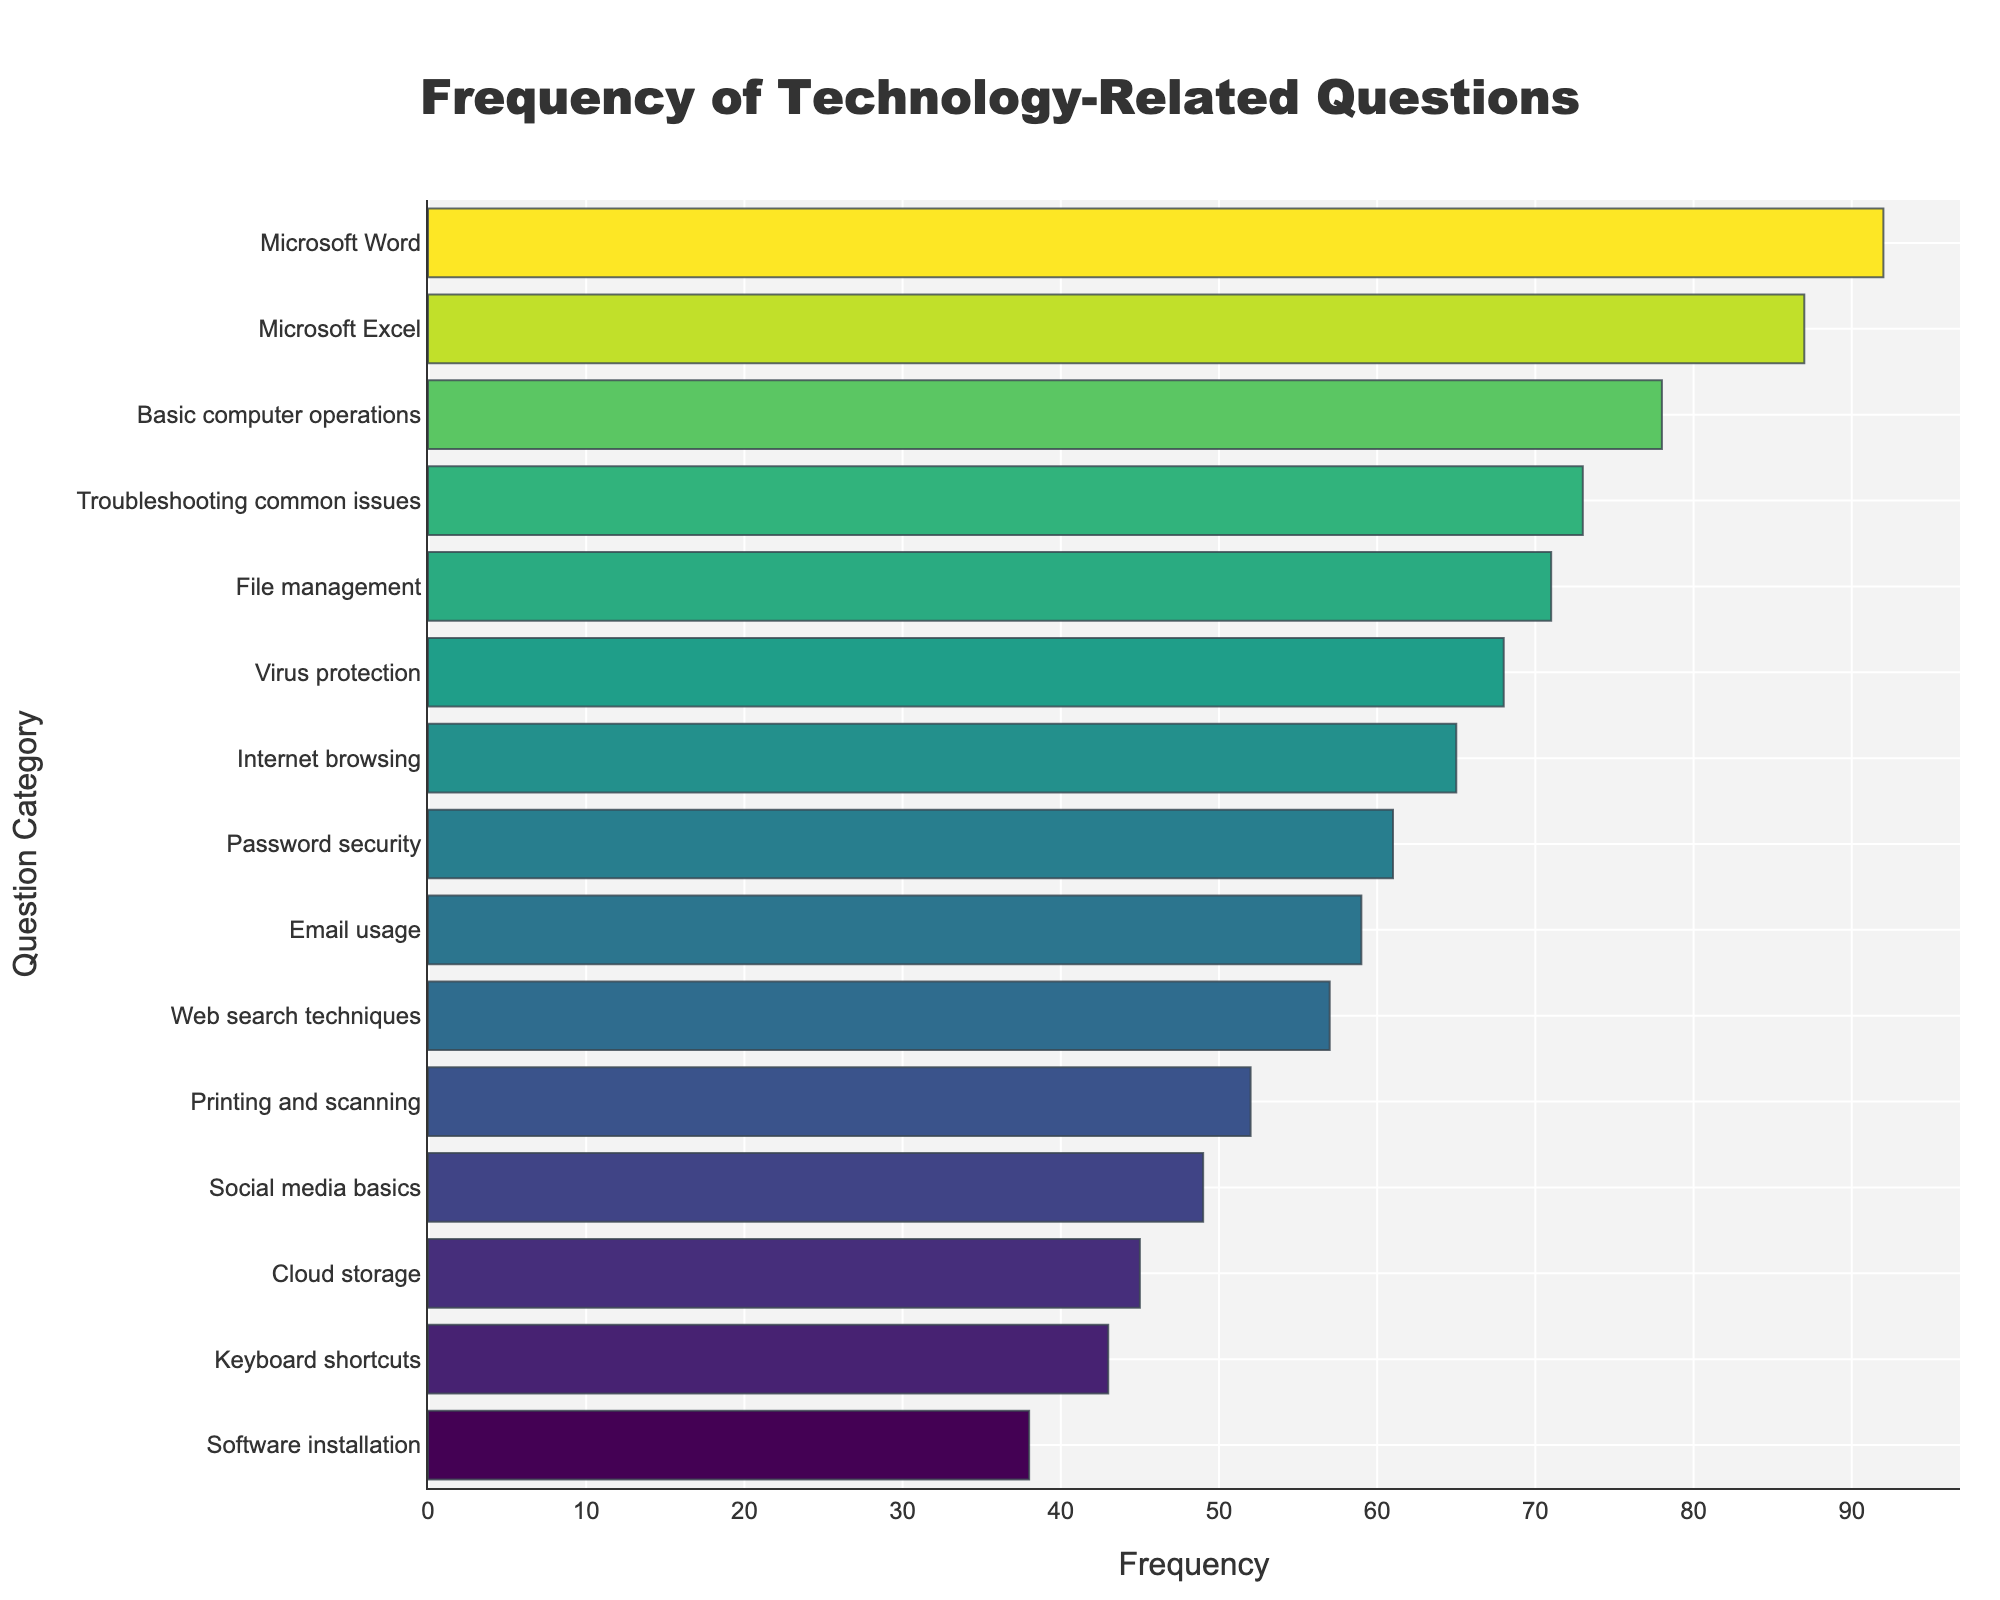What's the title of the figure? The title is usually displayed prominently at the top of the figure. Here, it reads 'Frequency of Technology-Related Questions'.
Answer: Frequency of Technology-Related Questions How many question categories are represented in the figure? To find this, count the number of distinct bars on the plot. Each bar represents a unique question category.
Answer: 15 Which question has the highest frequency? Look at the bar that extends the farthest to the right; this represents the highest frequency. 'Microsoft Word' appears to have the longest bar.
Answer: Microsoft Word What's the frequency of "Software installation" questions? Locate the bar corresponding to 'Software installation' and look at its length or corresponding value on the x-axis. The frequency is visible next to this bar.
Answer: 38 How does the frequency of 'Password security' compare to 'Keyboard shortcuts'? Compare the lengths of the bars for 'Password security' and 'Keyboard shortcuts'. 'Password security' has a higher frequency than 'Keyboard shortcuts'.
Answer: Password security has a higher frequency What is the total frequency of 'Virus protection', 'Troubleshooting common issues', and 'Email usage' questions combined? Sum up the frequencies of the three categories: Virus protection (68), Troubleshooting common issues (73), and Email usage (59). Total = 68 + 73 + 59.
Answer: 200 Which question categories have a frequency higher than 60? Identify the bars where the x-axis value exceeds 60. These are Basic computer operations (78), Microsoft Word (92), Microsoft Excel (87), File management (71), Password security (61), Virus protection (68), Troubleshooting common issues (73), and Internet browsing (65).
Answer: Basic computer operations, Microsoft Word, Microsoft Excel, File management, Password security, Virus protection, Troubleshooting common issues, Internet browsing What is the median frequency value of the dataset? First, list out the frequencies in ascending order: 38, 43, 45, 49, 52, 57, 59, 61, 65, 68, 71, 73, 78, 87, 92. The median is the middle value. Since there are 15 data points, the median is the 8th value: 65.
Answer: 65 Which question category has a frequency closest to the average frequency? To find the average frequency, sum all the frequencies and divide by the total number of categories: (38 + 43 + 45 + 49 + 52 + 57 + 59 + 61 + 65 + 68 + 71 + 73 + 78 + 87 + 92) / 15 ≈ 63. Identify the bar closest to this value, which is 'Password security' with a frequency of 61.
Answer: Password security Between "Internet browsing" and "Cloud storage," which category has fewer questions? Compare the lengths of the bars for 'Internet browsing' and 'Cloud storage'. 'Cloud storage' has fewer questions with a frequency of 45 compared to 65 for 'Internet browsing'.
Answer: Cloud storage 